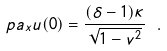<formula> <loc_0><loc_0><loc_500><loc_500>\ p a _ { x } u ( 0 ) = \frac { ( \delta - 1 ) \kappa } { \sqrt { 1 - v ^ { 2 } } } \ .</formula> 